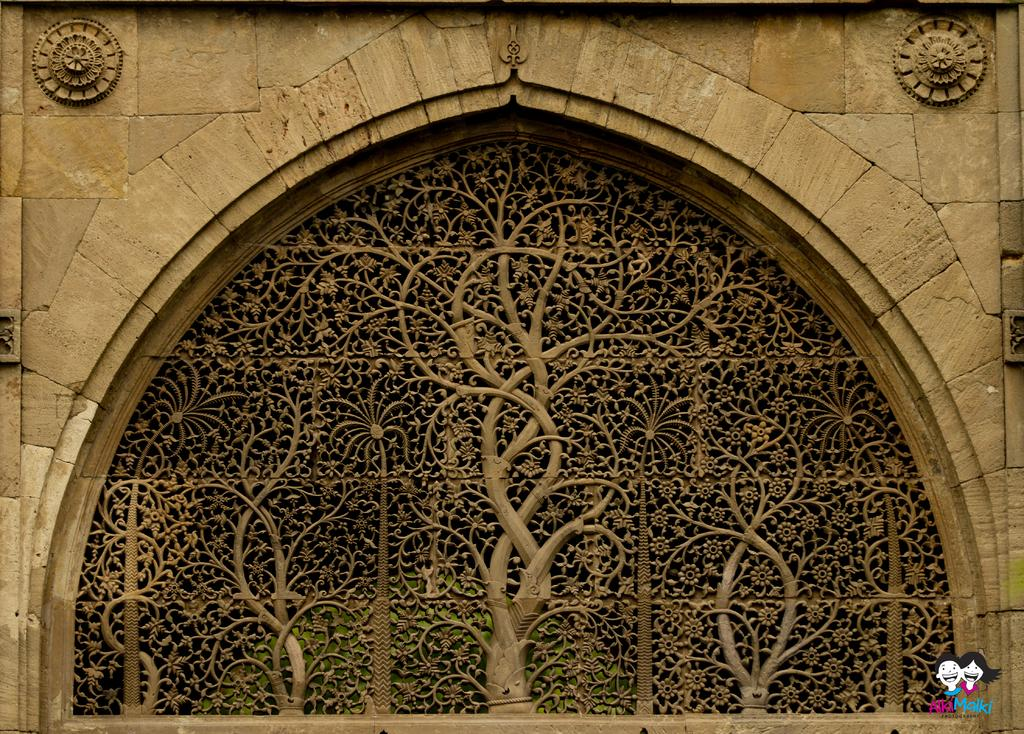What type of architectural feature is present in the image? There is a carved window in the image. Where is the carved window located? The carved window is part of a wall. Is there any branding or identification in the image? Yes, there is a logo in the bottom right-hand corner of the image. What type of sack can be seen hanging from the carved window in the image? There is no sack present in the image; it only features a carved window and a logo. What type of teeth can be seen in the image? There are no teeth visible in the image; it only features a carved window and a logo. 